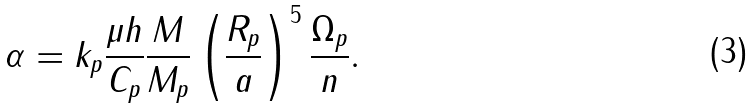Convert formula to latex. <formula><loc_0><loc_0><loc_500><loc_500>\alpha = k _ { p } \frac { \mu h } { C _ { p } } \frac { M } { M _ { p } } \left ( \frac { R _ { p } } { a } \right ) ^ { 5 } \frac { \Omega _ { p } } { n } .</formula> 